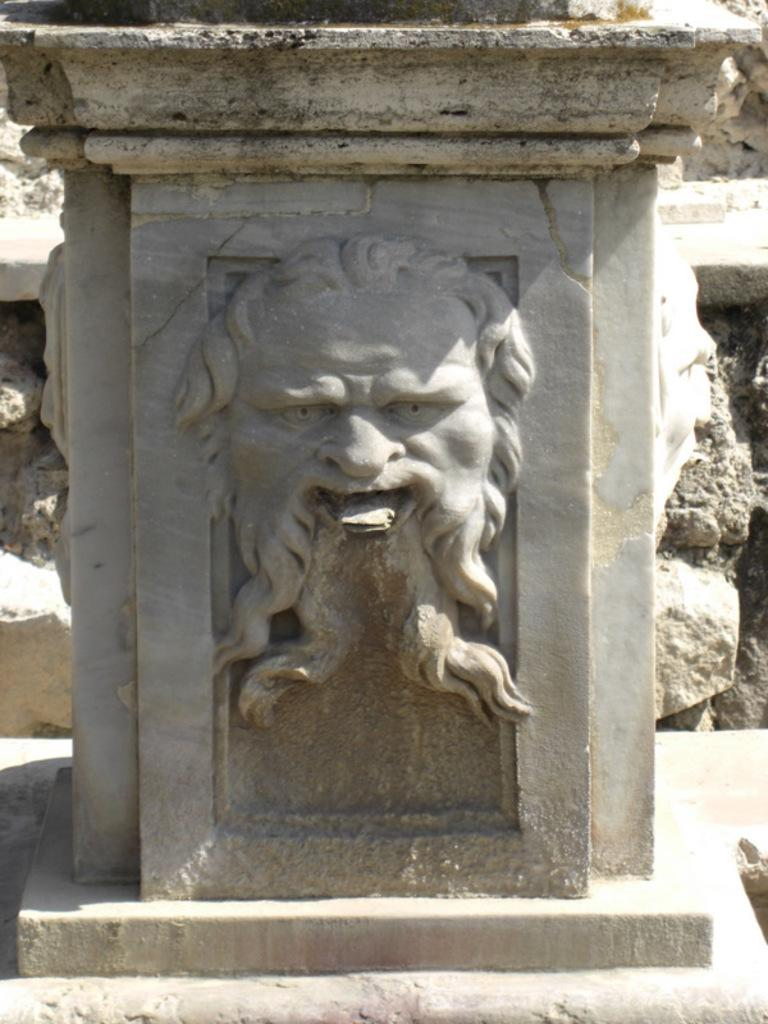What is the main subject of the image? The main subject of the image is a stone carving. What type of milk is being served to the manager in the image? There is no milk or manager present in the image; it features a stone carving. Is the person depicted in the stone carving sleeping or awake? The image does not depict a person, but rather a stone carving, so it is not possible to determine if the subject is sleeping or awake. 